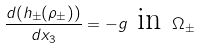<formula> <loc_0><loc_0><loc_500><loc_500>\frac { d ( h _ { \pm } ( \rho _ { \pm } ) ) } { d x _ { 3 } } = - g \text { in } \Omega _ { \pm }</formula> 